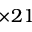Convert formula to latex. <formula><loc_0><loc_0><loc_500><loc_500>\times 2 1</formula> 